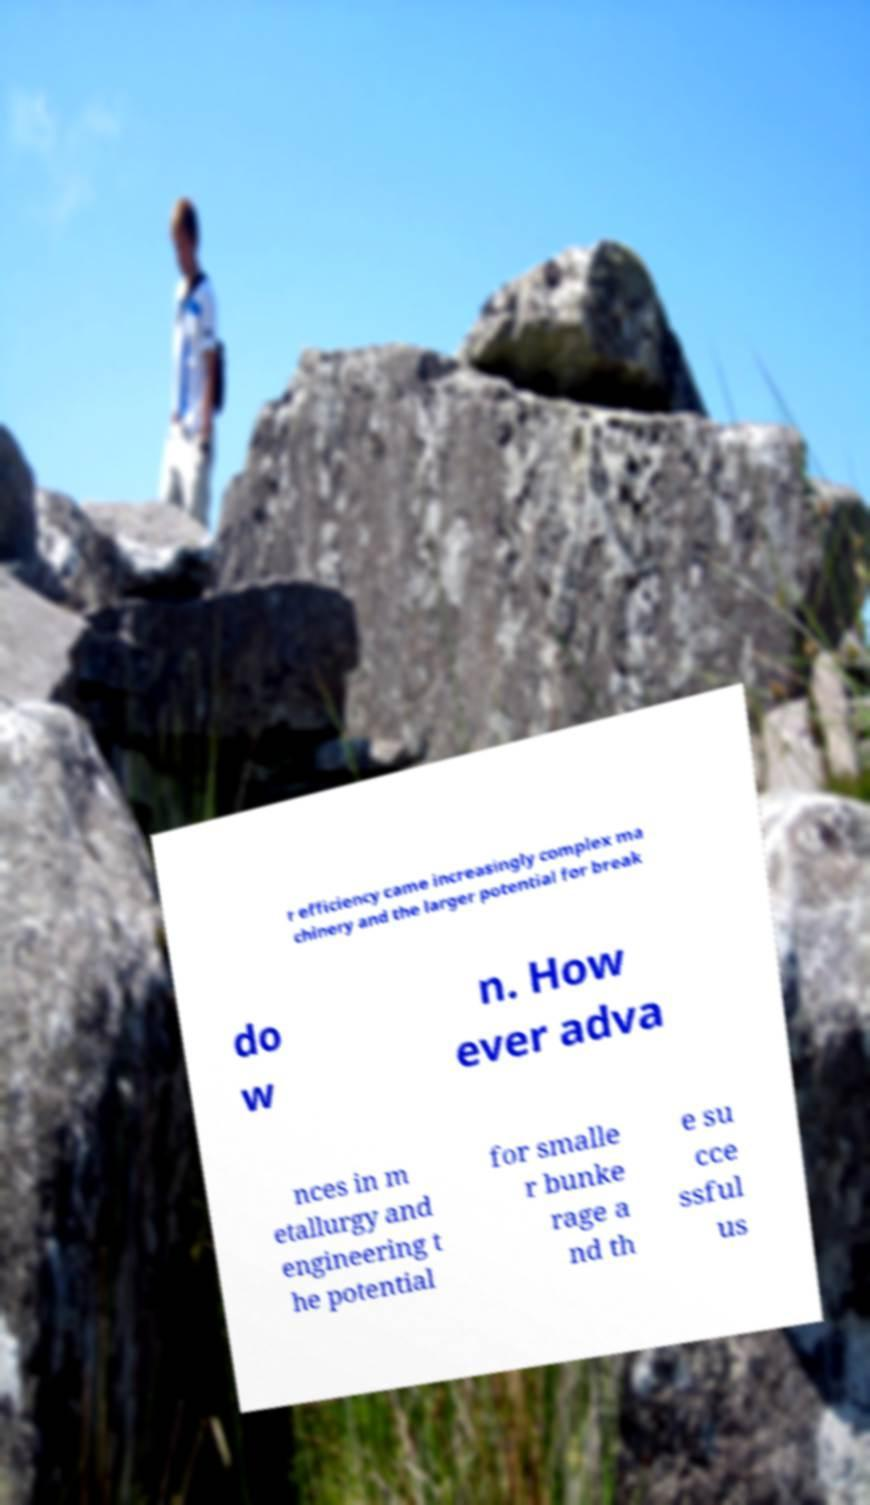What messages or text are displayed in this image? I need them in a readable, typed format. r efficiency came increasingly complex ma chinery and the larger potential for break do w n. How ever adva nces in m etallurgy and engineering t he potential for smalle r bunke rage a nd th e su cce ssful us 